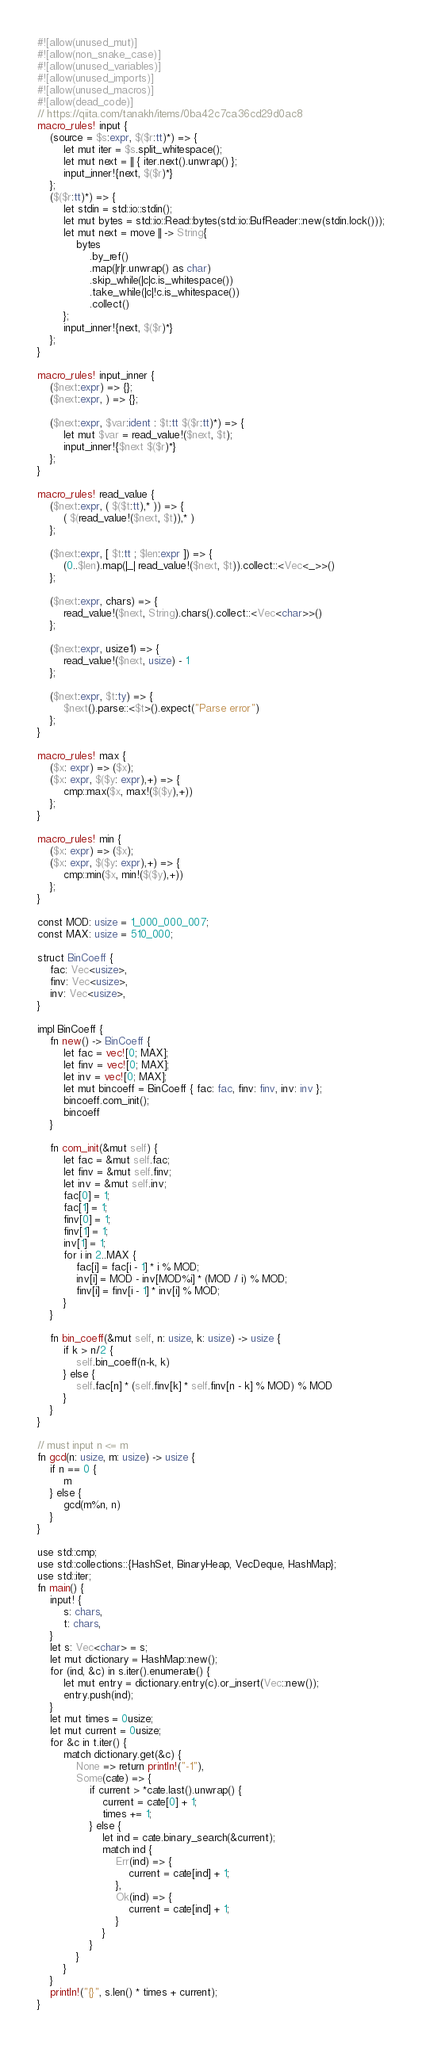<code> <loc_0><loc_0><loc_500><loc_500><_Rust_>#![allow(unused_mut)]
#![allow(non_snake_case)]
#![allow(unused_variables)]
#![allow(unused_imports)]
#![allow(unused_macros)]
#![allow(dead_code)]
// https://qiita.com/tanakh/items/0ba42c7ca36cd29d0ac8
macro_rules! input {
    (source = $s:expr, $($r:tt)*) => {
        let mut iter = $s.split_whitespace();
        let mut next = || { iter.next().unwrap() };
        input_inner!{next, $($r)*}
    };
    ($($r:tt)*) => {
        let stdin = std::io::stdin();
        let mut bytes = std::io::Read::bytes(std::io::BufReader::new(stdin.lock()));
        let mut next = move || -> String{
            bytes
                .by_ref()
                .map(|r|r.unwrap() as char)
                .skip_while(|c|c.is_whitespace())
                .take_while(|c|!c.is_whitespace())
                .collect()
        };
        input_inner!{next, $($r)*}
    };
}

macro_rules! input_inner {
    ($next:expr) => {};
    ($next:expr, ) => {};

    ($next:expr, $var:ident : $t:tt $($r:tt)*) => {
        let mut $var = read_value!($next, $t);
        input_inner!{$next $($r)*}
    };
}

macro_rules! read_value {
    ($next:expr, ( $($t:tt),* )) => {
        ( $(read_value!($next, $t)),* )
    };

    ($next:expr, [ $t:tt ; $len:expr ]) => {
        (0..$len).map(|_| read_value!($next, $t)).collect::<Vec<_>>()
    };

    ($next:expr, chars) => {
        read_value!($next, String).chars().collect::<Vec<char>>()
    };

    ($next:expr, usize1) => {
        read_value!($next, usize) - 1
    };

    ($next:expr, $t:ty) => {
        $next().parse::<$t>().expect("Parse error")
    };
}

macro_rules! max {
    ($x: expr) => ($x);
    ($x: expr, $($y: expr),+) => {
        cmp::max($x, max!($($y),+))
    };
}

macro_rules! min {
    ($x: expr) => ($x);
    ($x: expr, $($y: expr),+) => {
        cmp::min($x, min!($($y),+))
    };
}

const MOD: usize = 1_000_000_007;
const MAX: usize = 510_000;

struct BinCoeff {
    fac: Vec<usize>,
    finv: Vec<usize>,
    inv: Vec<usize>,
}

impl BinCoeff {
    fn new() -> BinCoeff {
        let fac = vec![0; MAX];
        let finv = vec![0; MAX];
        let inv = vec![0; MAX];
        let mut bincoeff = BinCoeff { fac: fac, finv: finv, inv: inv };
        bincoeff.com_init();
        bincoeff
    }

    fn com_init(&mut self) {
        let fac = &mut self.fac;
        let finv = &mut self.finv;
        let inv = &mut self.inv;
        fac[0] = 1;
        fac[1] = 1;
        finv[0] = 1;
        finv[1] = 1;
        inv[1] = 1;
        for i in 2..MAX {
            fac[i] = fac[i - 1] * i % MOD;
            inv[i] = MOD - inv[MOD%i] * (MOD / i) % MOD;
            finv[i] = finv[i - 1] * inv[i] % MOD;
        }
    }

    fn bin_coeff(&mut self, n: usize, k: usize) -> usize {
        if k > n/2 {
            self.bin_coeff(n-k, k)
        } else {
            self.fac[n] * (self.finv[k] * self.finv[n - k] % MOD) % MOD
        }
    }
}

// must input n <= m
fn gcd(n: usize, m: usize) -> usize {
    if n == 0 {
        m
    } else {
        gcd(m%n, n)
    }
}

use std::cmp;
use std::collections::{HashSet, BinaryHeap, VecDeque, HashMap};
use std::iter;
fn main() {
    input! {
        s: chars,
        t: chars,
    }
    let s: Vec<char> = s;
    let mut dictionary = HashMap::new();
    for (ind, &c) in s.iter().enumerate() {
        let mut entry = dictionary.entry(c).or_insert(Vec::new());
        entry.push(ind);
    }
    let mut times = 0usize;
    let mut current = 0usize;
    for &c in t.iter() {
        match dictionary.get(&c) {
            None => return println!("-1"),
            Some(cate) => {
                if current > *cate.last().unwrap() {
                    current = cate[0] + 1;
                    times += 1;
                } else {
                    let ind = cate.binary_search(&current);
                    match ind {
                        Err(ind) => {
                            current = cate[ind] + 1;
                        },
                        Ok(ind) => {
                            current = cate[ind] + 1;
                        }
                    }
                }
            }
        }
    }
    println!("{}", s.len() * times + current);
}</code> 